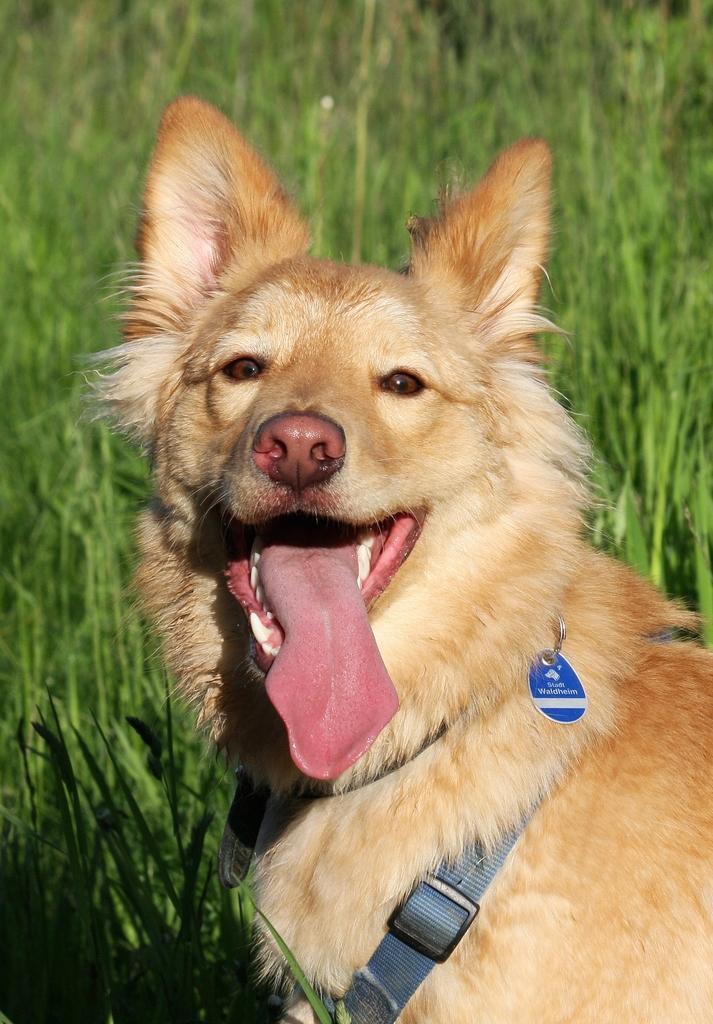How would you summarize this image in a sentence or two? In this picture we can see a dog in the front, in the background there is some grass, we can see strap here. 